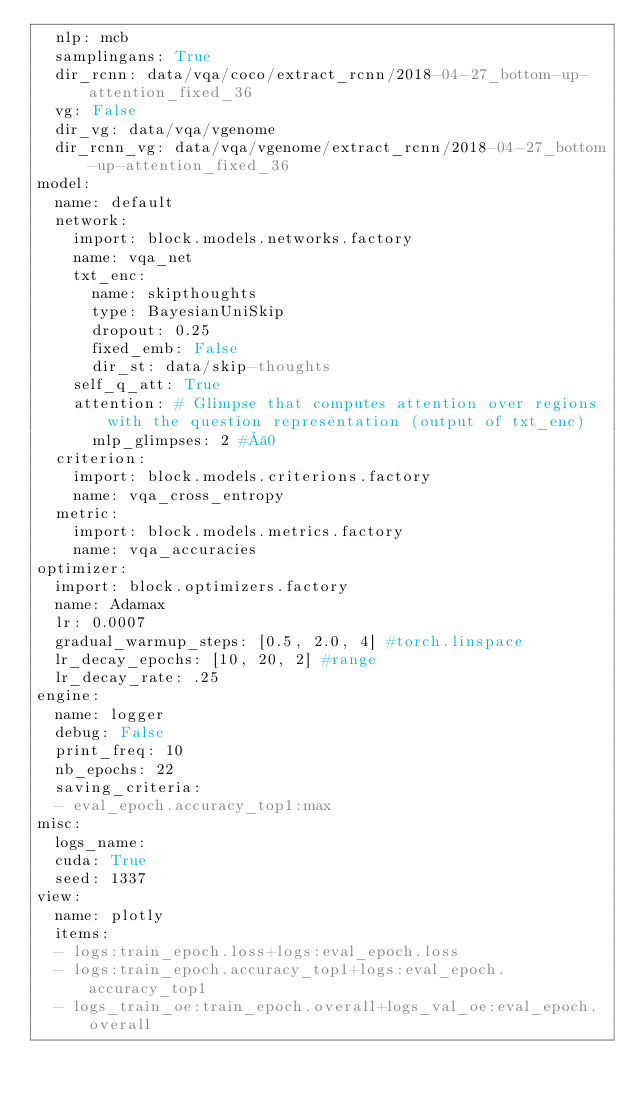Convert code to text. <code><loc_0><loc_0><loc_500><loc_500><_YAML_>  nlp: mcb
  samplingans: True
  dir_rcnn: data/vqa/coco/extract_rcnn/2018-04-27_bottom-up-attention_fixed_36
  vg: False
  dir_vg: data/vqa/vgenome
  dir_rcnn_vg: data/vqa/vgenome/extract_rcnn/2018-04-27_bottom-up-attention_fixed_36
model:
  name: default
  network:
    import: block.models.networks.factory
    name: vqa_net
    txt_enc:
      name: skipthoughts
      type: BayesianUniSkip
      dropout: 0.25
      fixed_emb: False
      dir_st: data/skip-thoughts
    self_q_att: True
    attention: # Glimpse that computes attention over regions with the question representation (output of txt_enc)
      mlp_glimpses: 2 # 0
  criterion:
    import: block.models.criterions.factory
    name: vqa_cross_entropy
  metric:
    import: block.models.metrics.factory
    name: vqa_accuracies
optimizer:
  import: block.optimizers.factory
  name: Adamax
  lr: 0.0007
  gradual_warmup_steps: [0.5, 2.0, 4] #torch.linspace
  lr_decay_epochs: [10, 20, 2] #range
  lr_decay_rate: .25
engine:
  name: logger
  debug: False
  print_freq: 10
  nb_epochs: 22
  saving_criteria:
  - eval_epoch.accuracy_top1:max
misc:
  logs_name:
  cuda: True
  seed: 1337
view:
  name: plotly
  items:
  - logs:train_epoch.loss+logs:eval_epoch.loss
  - logs:train_epoch.accuracy_top1+logs:eval_epoch.accuracy_top1
  - logs_train_oe:train_epoch.overall+logs_val_oe:eval_epoch.overall
</code> 